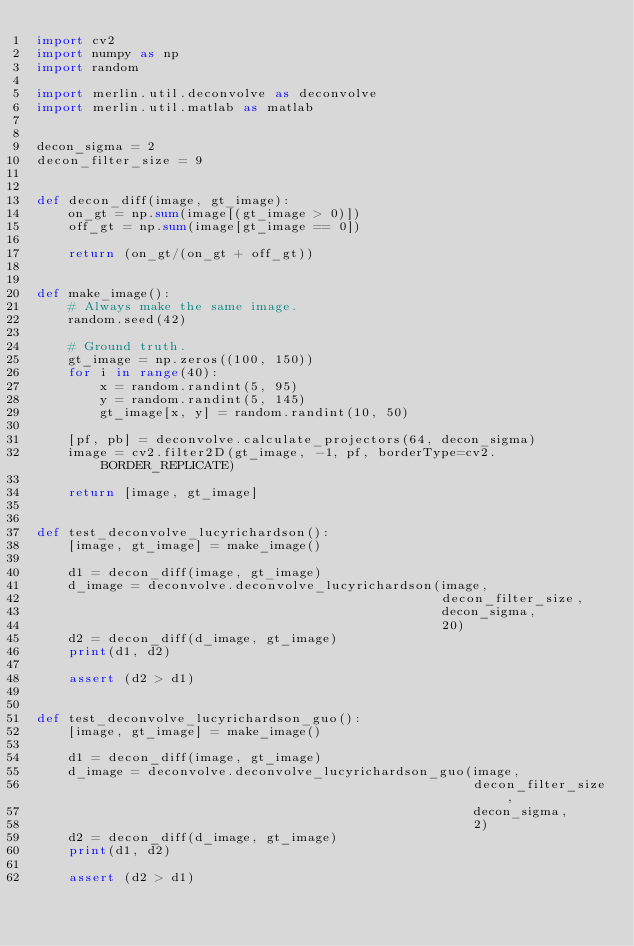<code> <loc_0><loc_0><loc_500><loc_500><_Python_>import cv2
import numpy as np
import random

import merlin.util.deconvolve as deconvolve
import merlin.util.matlab as matlab


decon_sigma = 2
decon_filter_size = 9


def decon_diff(image, gt_image):
    on_gt = np.sum(image[(gt_image > 0)])
    off_gt = np.sum(image[gt_image == 0])

    return (on_gt/(on_gt + off_gt))


def make_image():
    # Always make the same image.
    random.seed(42)

    # Ground truth.
    gt_image = np.zeros((100, 150))
    for i in range(40):
        x = random.randint(5, 95)
        y = random.randint(5, 145)
        gt_image[x, y] = random.randint(10, 50)

    [pf, pb] = deconvolve.calculate_projectors(64, decon_sigma)
    image = cv2.filter2D(gt_image, -1, pf, borderType=cv2.BORDER_REPLICATE)

    return [image, gt_image]


def test_deconvolve_lucyrichardson():
    [image, gt_image] = make_image()

    d1 = decon_diff(image, gt_image)
    d_image = deconvolve.deconvolve_lucyrichardson(image,
                                                   decon_filter_size,
                                                   decon_sigma,
                                                   20)
    d2 = decon_diff(d_image, gt_image)
    print(d1, d2)

    assert (d2 > d1)


def test_deconvolve_lucyrichardson_guo():
    [image, gt_image] = make_image()

    d1 = decon_diff(image, gt_image)
    d_image = deconvolve.deconvolve_lucyrichardson_guo(image,
                                                       decon_filter_size,
                                                       decon_sigma,
                                                       2)
    d2 = decon_diff(d_image, gt_image)
    print(d1, d2)

    assert (d2 > d1)
</code> 